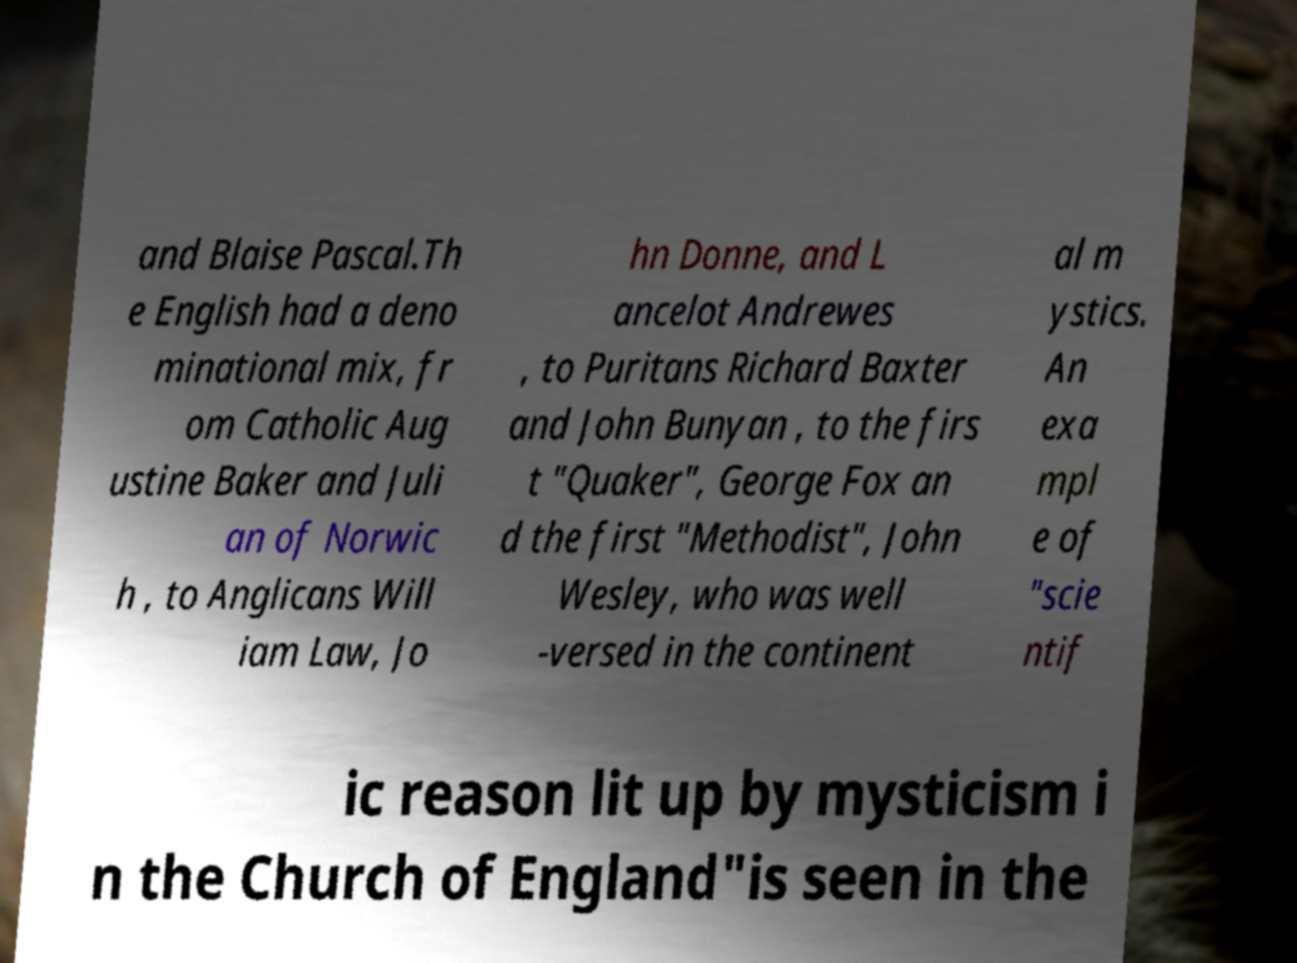Can you accurately transcribe the text from the provided image for me? and Blaise Pascal.Th e English had a deno minational mix, fr om Catholic Aug ustine Baker and Juli an of Norwic h , to Anglicans Will iam Law, Jo hn Donne, and L ancelot Andrewes , to Puritans Richard Baxter and John Bunyan , to the firs t "Quaker", George Fox an d the first "Methodist", John Wesley, who was well -versed in the continent al m ystics. An exa mpl e of "scie ntif ic reason lit up by mysticism i n the Church of England"is seen in the 